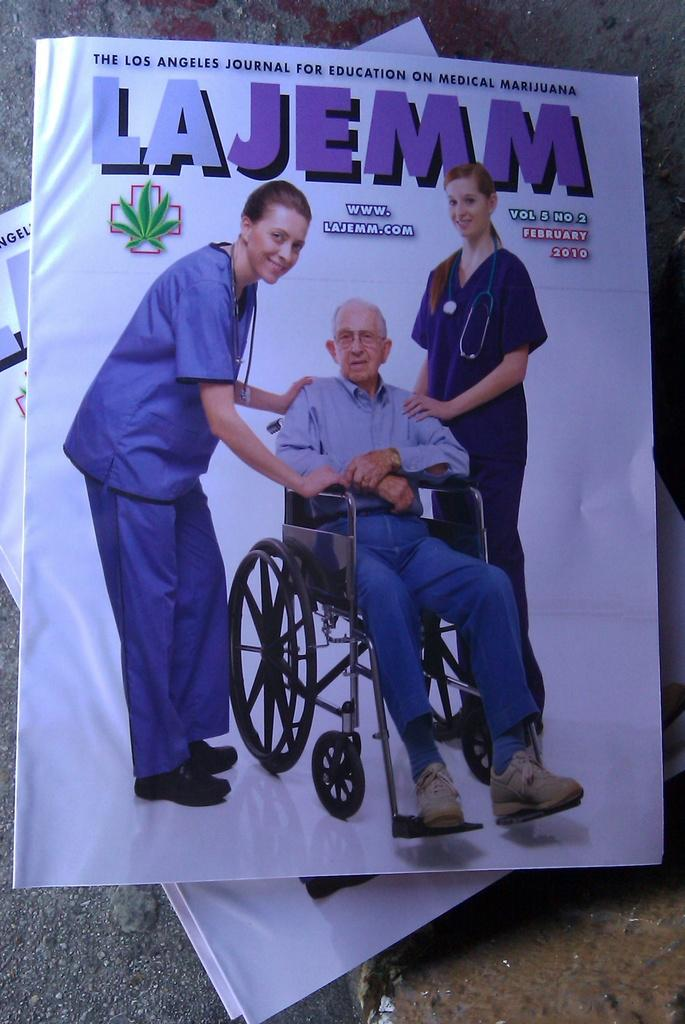What objects are present in the image? There are books in the image. What can be seen in the illustrations within the books? The books contain images of two women and a man. What is the man doing in the illustrations? The man is seated in a wheelchair. What type of cactus can be seen in the image? There is no cactus present in the image. What scent is emanating from the books in the image? The image does not provide any information about the scent of the books. 